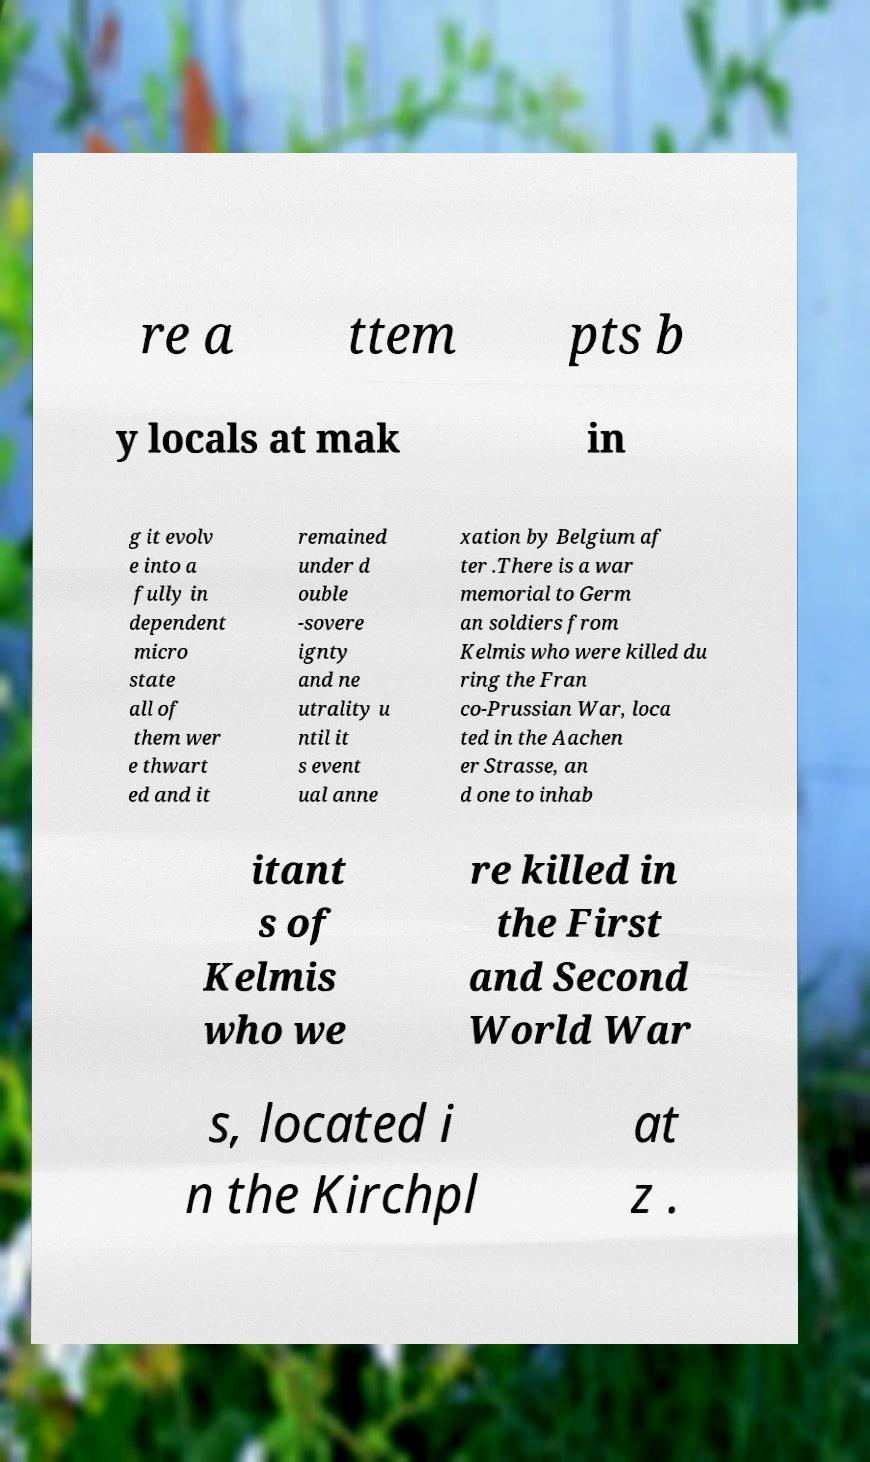Can you accurately transcribe the text from the provided image for me? re a ttem pts b y locals at mak in g it evolv e into a fully in dependent micro state all of them wer e thwart ed and it remained under d ouble -sovere ignty and ne utrality u ntil it s event ual anne xation by Belgium af ter .There is a war memorial to Germ an soldiers from Kelmis who were killed du ring the Fran co-Prussian War, loca ted in the Aachen er Strasse, an d one to inhab itant s of Kelmis who we re killed in the First and Second World War s, located i n the Kirchpl at z . 